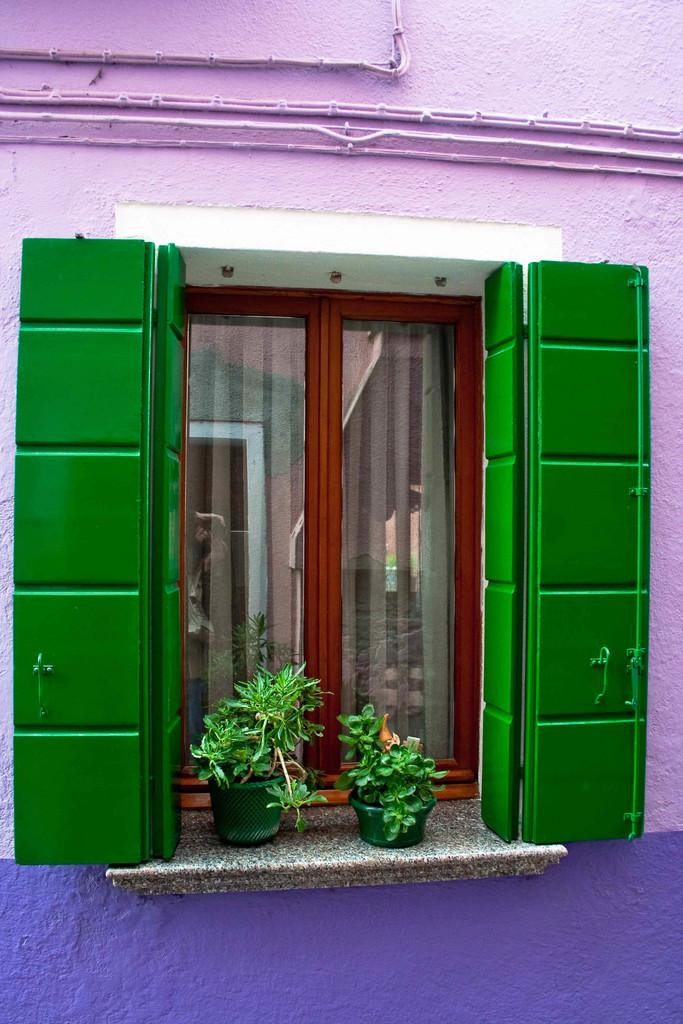What type of structure can be seen in the image? There is a wall in the image. What architectural feature is present in the wall? There is a window in the image. How many plants are visible in the image? There are two plants in the image. Where is the glass door located in the image? There is a glass door in the middle of the image. What type of badge is the person wearing in the image? There is no person present in the image, so it is not possible to determine if they are wearing a badge. 